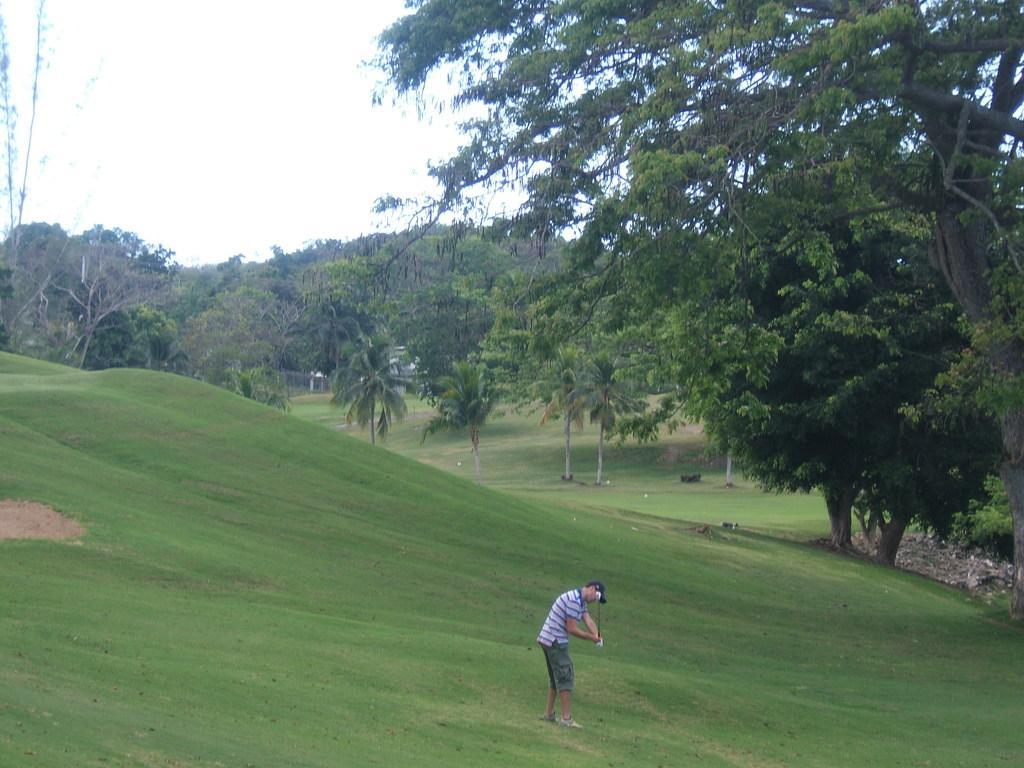Can you describe this image briefly? In this image, I can see a person standing. I can see the trees with branches and leaves. This is the grass. 